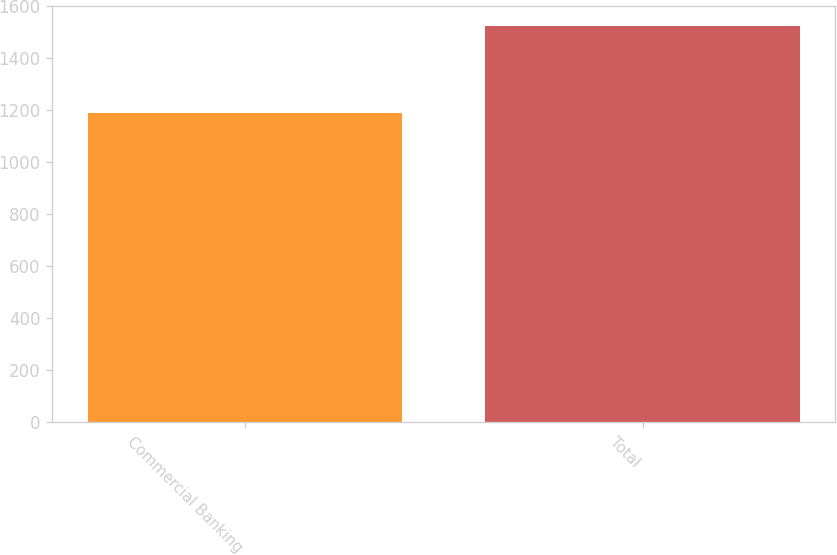Convert chart to OTSL. <chart><loc_0><loc_0><loc_500><loc_500><bar_chart><fcel>Commercial Banking<fcel>Total<nl><fcel>1187.7<fcel>1525.1<nl></chart> 